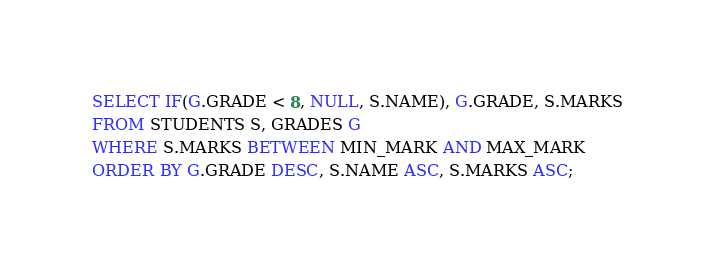Convert code to text. <code><loc_0><loc_0><loc_500><loc_500><_SQL_>SELECT IF(G.GRADE < 8, NULL, S.NAME), G.GRADE, S.MARKS
FROM STUDENTS S, GRADES G
WHERE S.MARKS BETWEEN MIN_MARK AND MAX_MARK
ORDER BY G.GRADE DESC, S.NAME ASC, S.MARKS ASC;</code> 